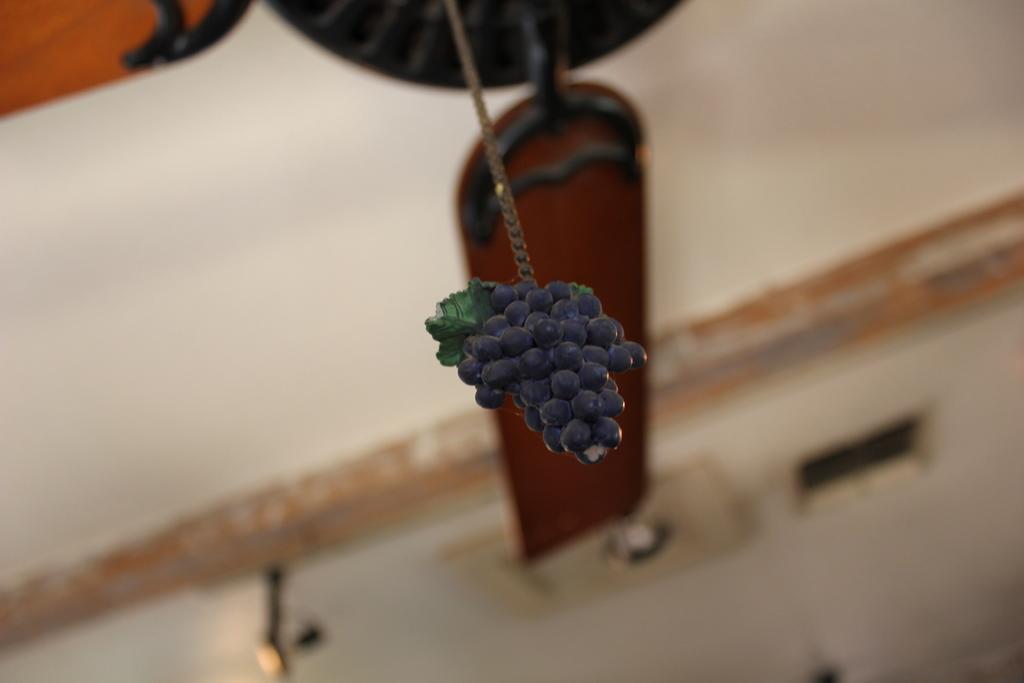Could you give a brief overview of what you see in this image? In this image we can see grapes, there are some other objects behind grapes, and the background is blurred. 